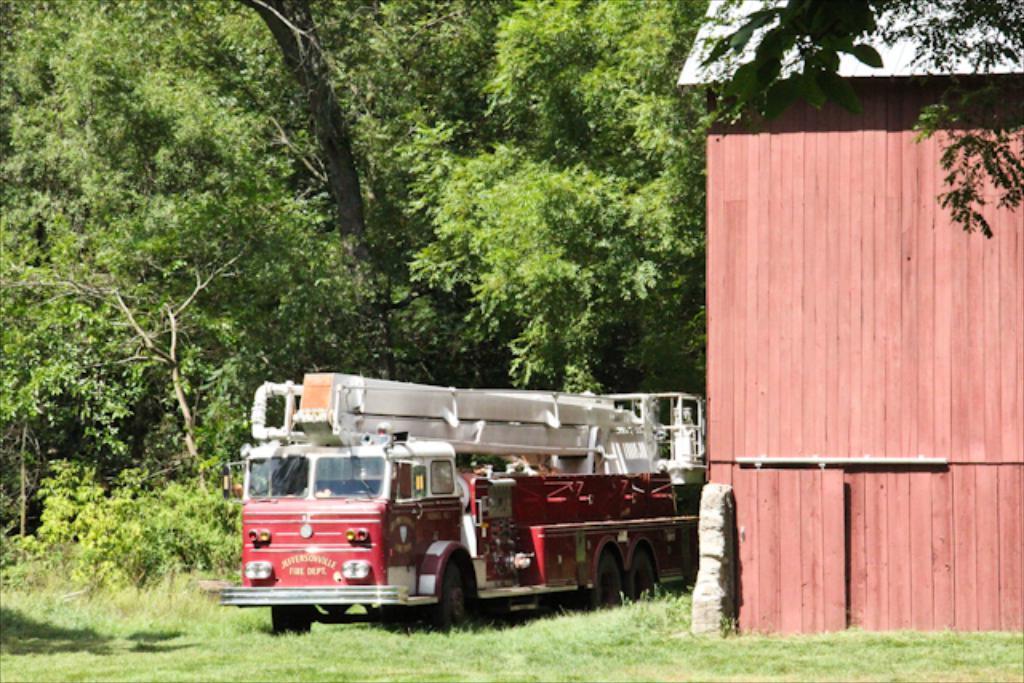Please provide a concise description of this image. In this image we can see a fire engine. Also there is a building with wooden wall. On the ground there is grass. In the background there are trees. 